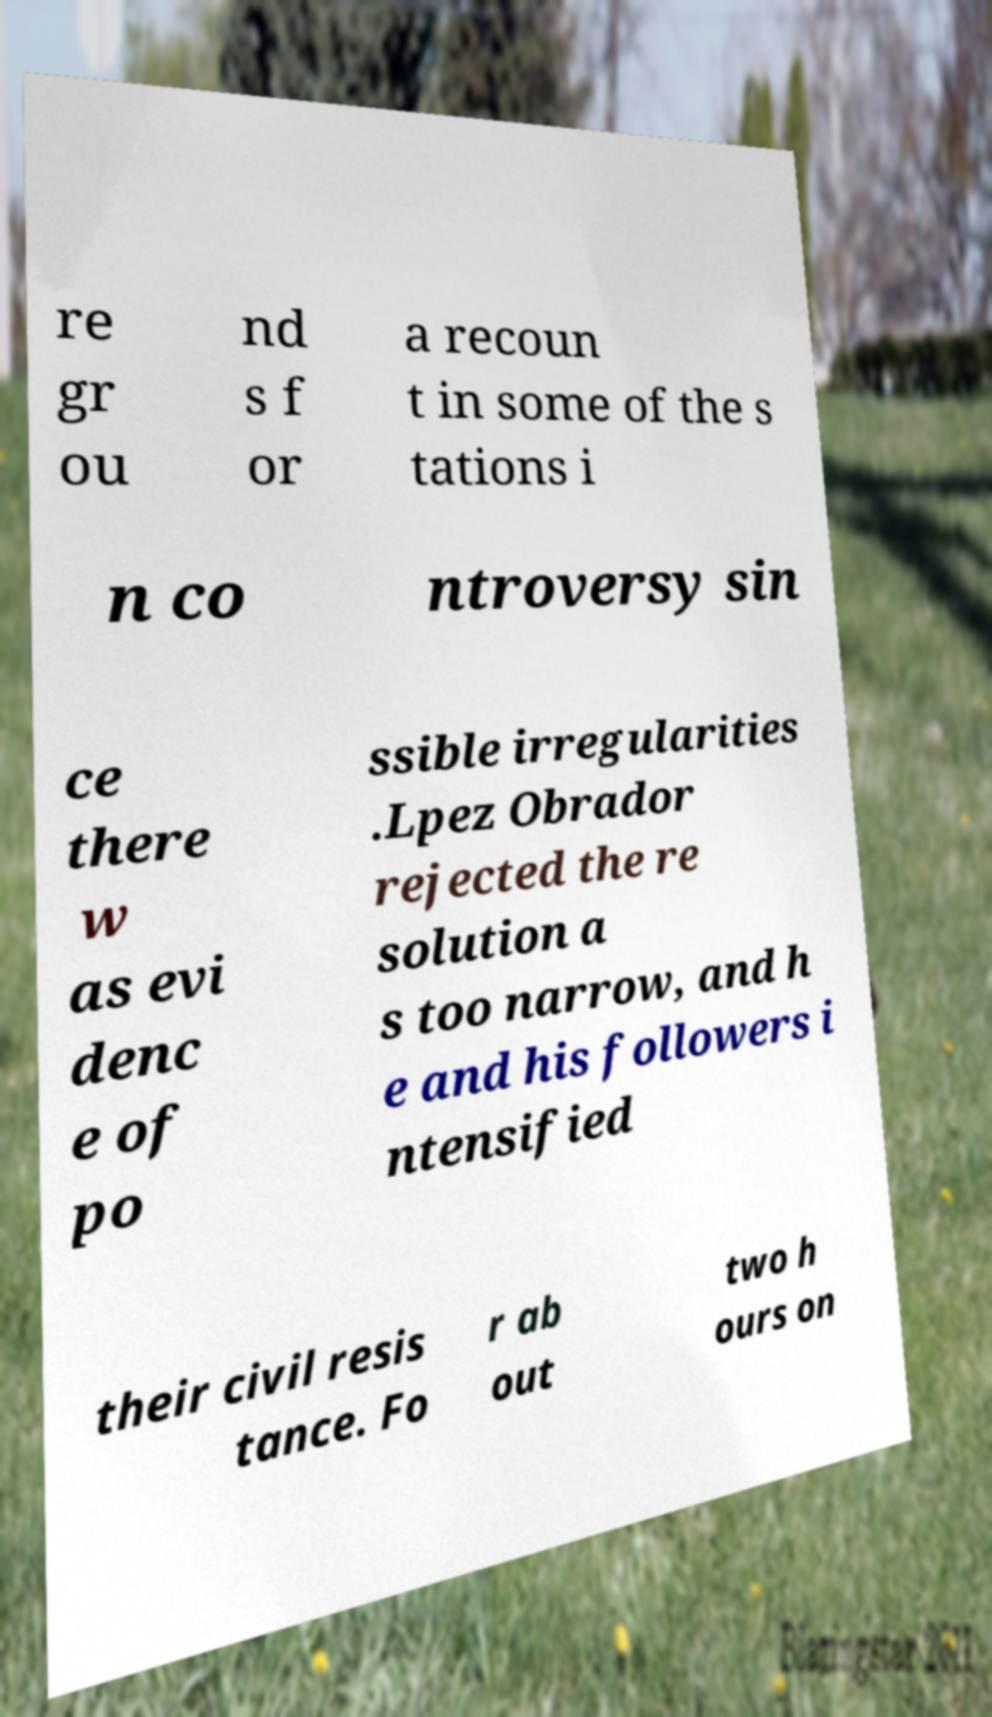Can you read and provide the text displayed in the image?This photo seems to have some interesting text. Can you extract and type it out for me? re gr ou nd s f or a recoun t in some of the s tations i n co ntroversy sin ce there w as evi denc e of po ssible irregularities .Lpez Obrador rejected the re solution a s too narrow, and h e and his followers i ntensified their civil resis tance. Fo r ab out two h ours on 